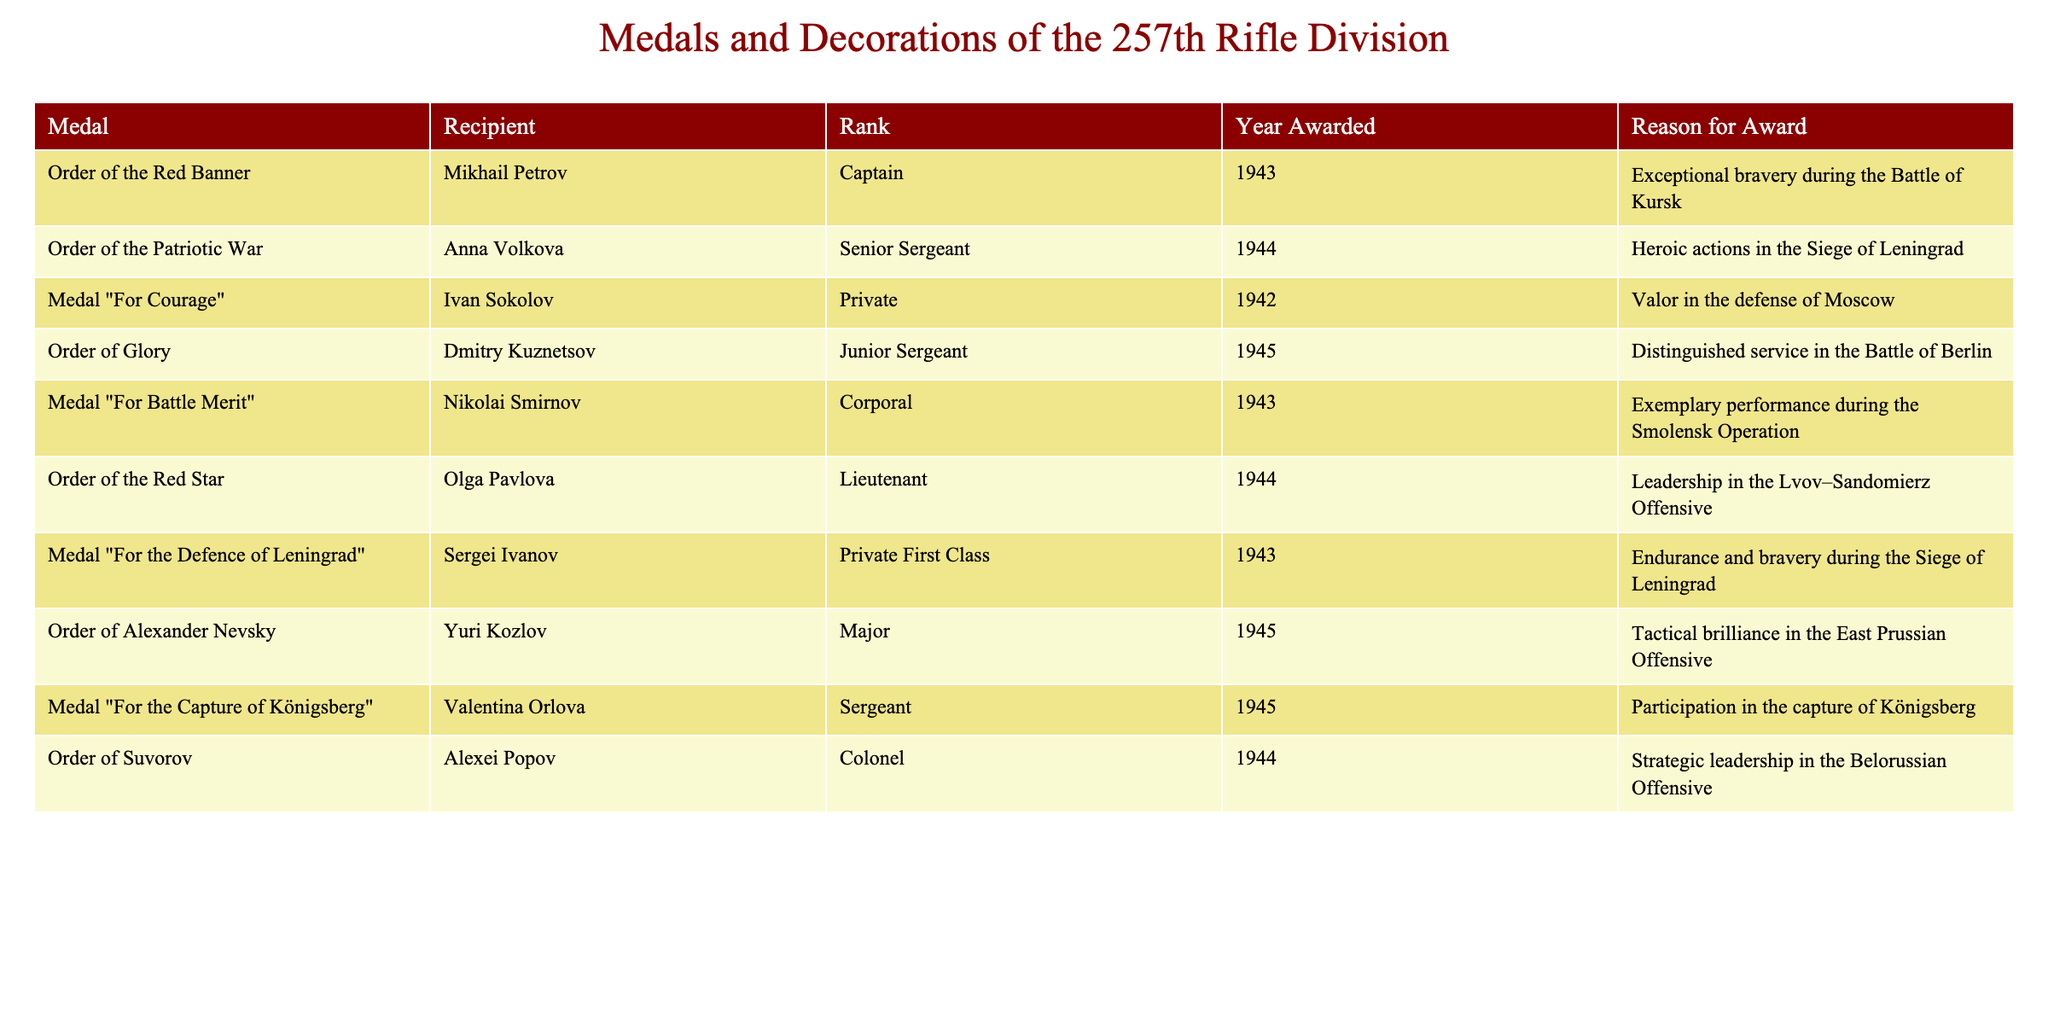What medal was awarded to Mikhail Petrov? The table shows that Mikhail Petrov received the Order of the Red Banner.
Answer: Order of the Red Banner How many recipients were awarded the Medal "For Courage"? Based on the table, only Ivan Sokolov is listed as the recipient of the Medal "For Courage." Thus, the count is 1.
Answer: 1 Which rank received the highest number of awards? By examining the ranks in the table, I notice that while various ranks are present, the rank of Private appears twice. Therefore, Private received the highest number of awards.
Answer: Private Was Anna Volkova awarded in 1943? The table indicates that Anna Volkova was awarded in 1944, not 1943. So this statement is false.
Answer: No Who received the Order of Glory and in what year? According to the table, Dmitry Kuznetsov received the Order of Glory in 1945.
Answer: Dmitry Kuznetsov, 1945 How many medals were awarded in 1944? Referring to the table, there are three medals awarded in 1944: the Order of the Patriotic War, the Order of the Red Star, and the Order of Suvorov. Thus, the count is 3.
Answer: 3 Which medal awarded to Valentina Orlova was given for her participation in the capture of Königsberg? The table specifies that Valentina Orlova was awarded the Medal "For the Capture of Königsberg."
Answer: Medal "For the Capture of Königsberg" Are there any awards that were given during the Siege of Leningrad? Upon reviewing the table, I find that there are two medals awarded for actions during the Siege of Leningrad: the Order of the Patriotic War to Anna Volkova and the Medal "For the Defence of Leningrad" to Sergei Ivanov.
Answer: Yes What is the relationship between the medals "For Courage" and "For Battle Merit"? The table reveals that both medals were awarded for distinct acts of bravery: "For Courage" to Ivan Sokolov for valor in defense of Moscow, and "For Battle Merit" to Nikolai Smirnov for exemplary performance during the Smolensk Operation, suggesting they both recognize courageous acts in battle but were for different contexts.
Answer: Distinct acts of bravery Which recipient had the highest military rank and what was the awarded medal? The table lists Alexei Popov as the highest-ranked recipient, holding the rank of Colonel, who received the Order of Suvorov.
Answer: Alexei Popov, Order of Suvorov 